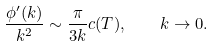Convert formula to latex. <formula><loc_0><loc_0><loc_500><loc_500>\frac { \phi ^ { \prime } ( k ) } { k ^ { 2 } } \sim \frac { \pi } { 3 k } c ( T ) , \quad k \to 0 .</formula> 